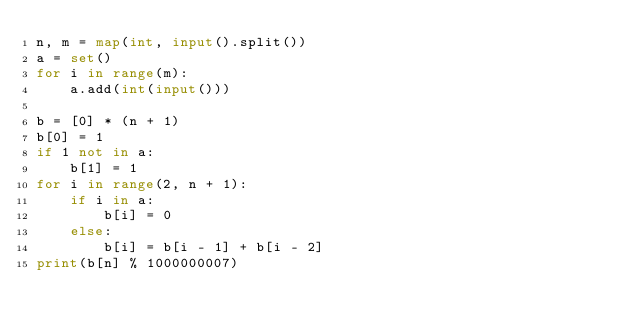Convert code to text. <code><loc_0><loc_0><loc_500><loc_500><_Python_>n, m = map(int, input().split())
a = set()
for i in range(m):
    a.add(int(input()))

b = [0] * (n + 1)
b[0] = 1
if 1 not in a:
    b[1] = 1
for i in range(2, n + 1):
    if i in a:
        b[i] = 0
    else:
        b[i] = b[i - 1] + b[i - 2]
print(b[n] % 1000000007)</code> 